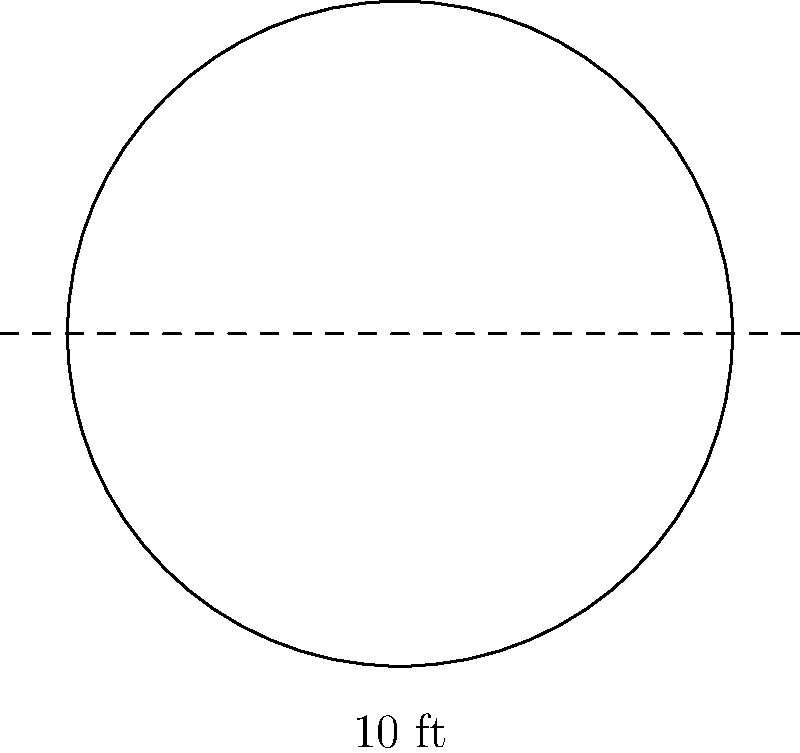The beautiful stained glass window in our church is circular in shape. If the diameter of the window is 10 feet, what is its area in square feet? (Use $\pi \approx 3.14$) To find the area of a circular window, we can follow these steps:

1) The formula for the area of a circle is:
   $$A = \pi r^2$$
   where $A$ is the area and $r$ is the radius.

2) We're given the diameter, which is 10 feet. The radius is half of the diameter:
   $$r = \frac{10}{2} = 5 \text{ feet}$$

3) Now we can substitute this into our formula:
   $$A = \pi (5)^2$$

4) Simplify:
   $$A = \pi (25)$$

5) Using $\pi \approx 3.14$:
   $$A \approx 3.14 (25) = 78.5 \text{ square feet}$$

Therefore, the area of the stained glass window is approximately 78.5 square feet.
Answer: 78.5 sq ft 